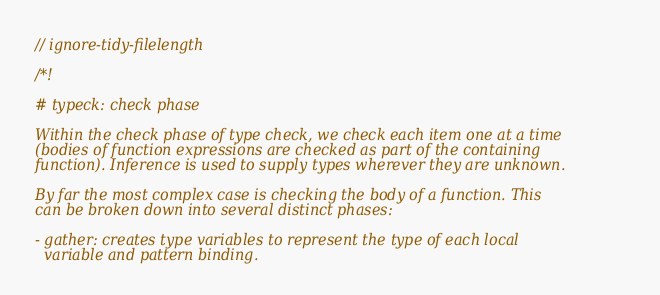Convert code to text. <code><loc_0><loc_0><loc_500><loc_500><_Rust_>// ignore-tidy-filelength

/*!

# typeck: check phase

Within the check phase of type check, we check each item one at a time
(bodies of function expressions are checked as part of the containing
function). Inference is used to supply types wherever they are unknown.

By far the most complex case is checking the body of a function. This
can be broken down into several distinct phases:

- gather: creates type variables to represent the type of each local
  variable and pattern binding.
</code> 